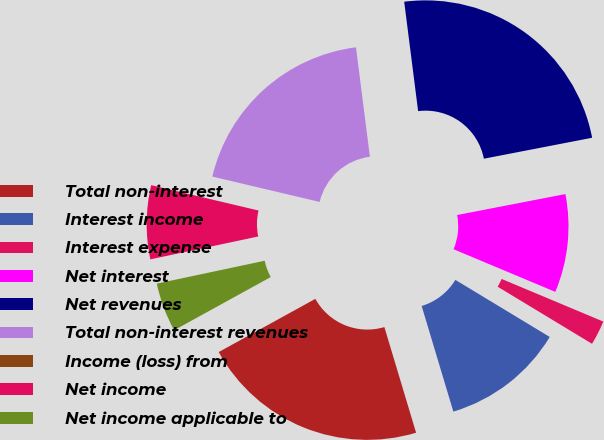Convert chart. <chart><loc_0><loc_0><loc_500><loc_500><pie_chart><fcel>Total non-interest<fcel>Interest income<fcel>Interest expense<fcel>Net interest<fcel>Net revenues<fcel>Total non-interest revenues<fcel>Income (loss) from<fcel>Net income<fcel>Net income applicable to<nl><fcel>21.63%<fcel>11.7%<fcel>2.34%<fcel>9.36%<fcel>23.97%<fcel>19.29%<fcel>0.0%<fcel>7.02%<fcel>4.68%<nl></chart> 